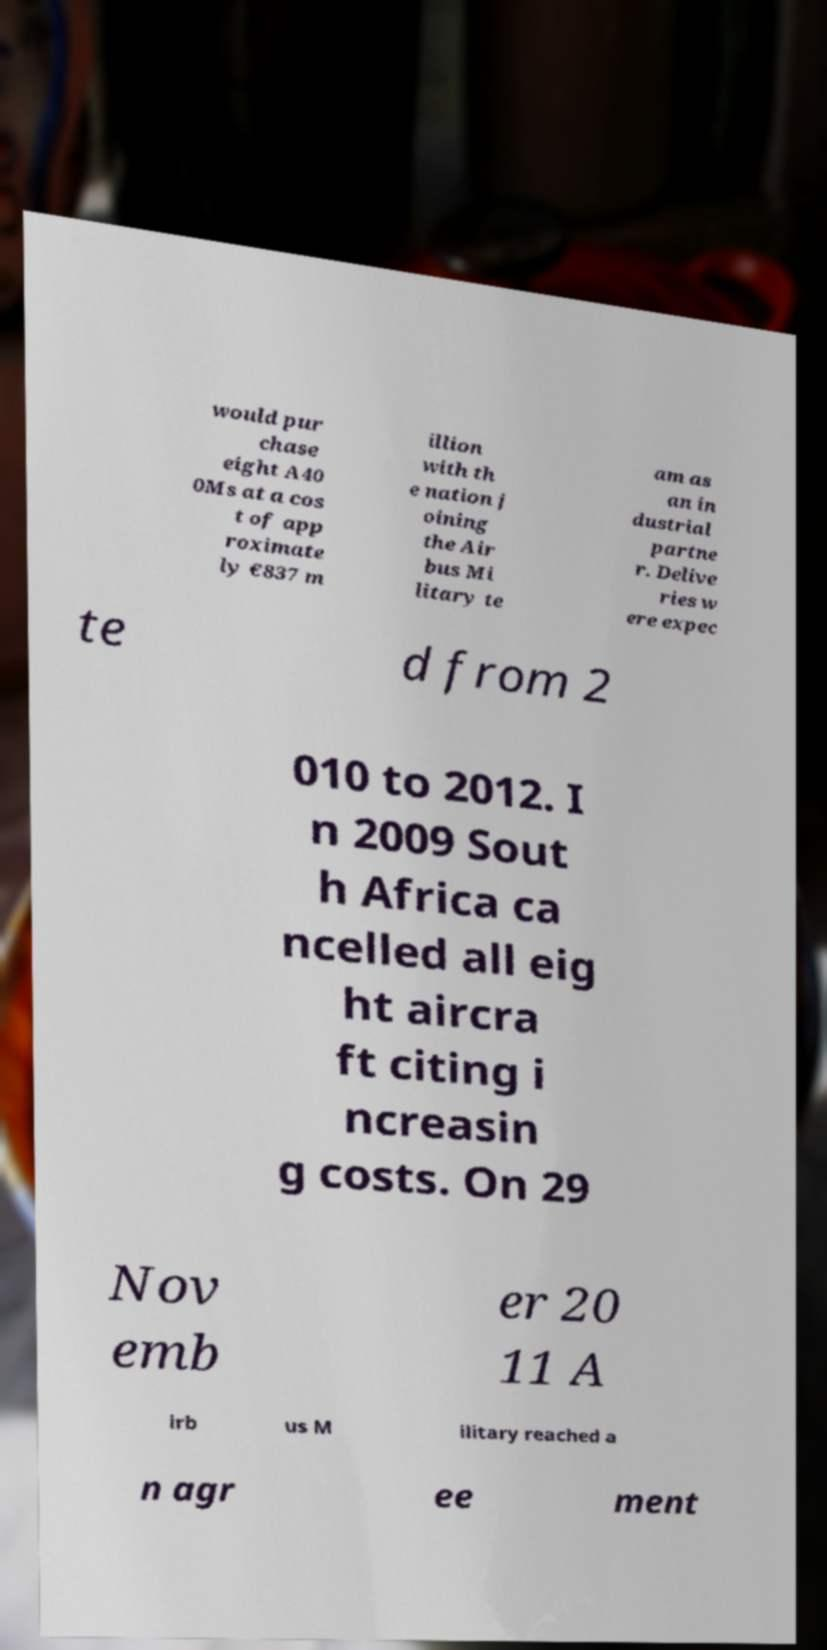Could you extract and type out the text from this image? would pur chase eight A40 0Ms at a cos t of app roximate ly €837 m illion with th e nation j oining the Air bus Mi litary te am as an in dustrial partne r. Delive ries w ere expec te d from 2 010 to 2012. I n 2009 Sout h Africa ca ncelled all eig ht aircra ft citing i ncreasin g costs. On 29 Nov emb er 20 11 A irb us M ilitary reached a n agr ee ment 